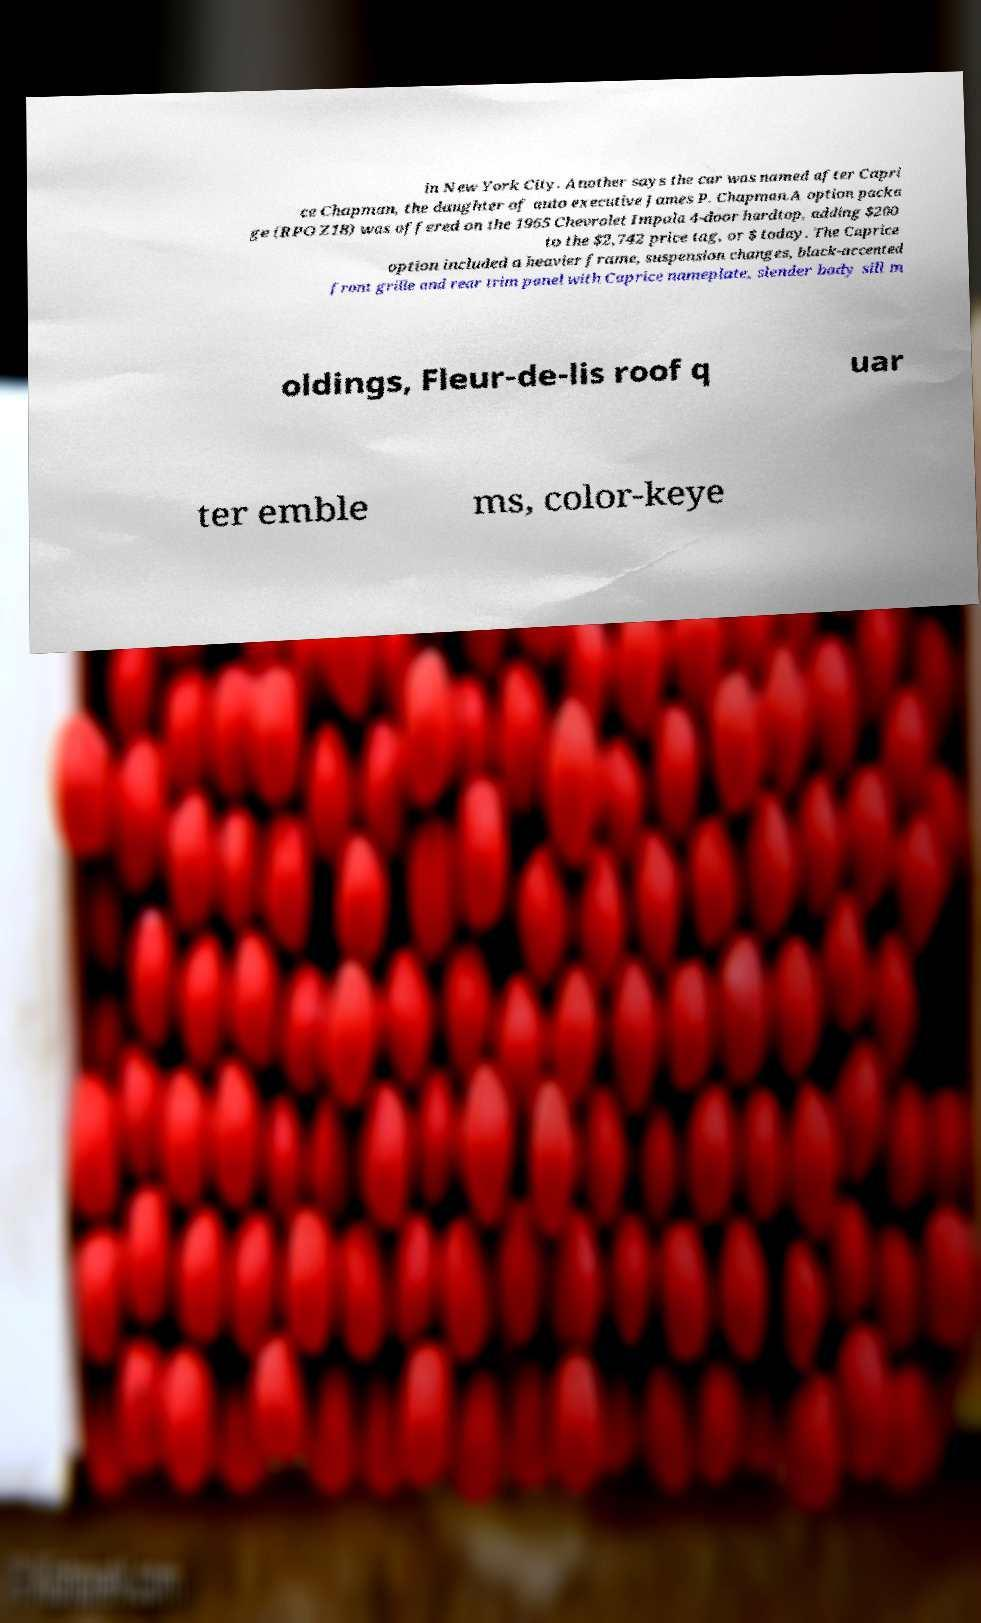Could you assist in decoding the text presented in this image and type it out clearly? in New York City. Another says the car was named after Capri ce Chapman, the daughter of auto executive James P. Chapman.A option packa ge (RPO Z18) was offered on the 1965 Chevrolet Impala 4-door hardtop, adding $200 to the $2,742 price tag, or $ today. The Caprice option included a heavier frame, suspension changes, black-accented front grille and rear trim panel with Caprice nameplate, slender body sill m oldings, Fleur-de-lis roof q uar ter emble ms, color-keye 